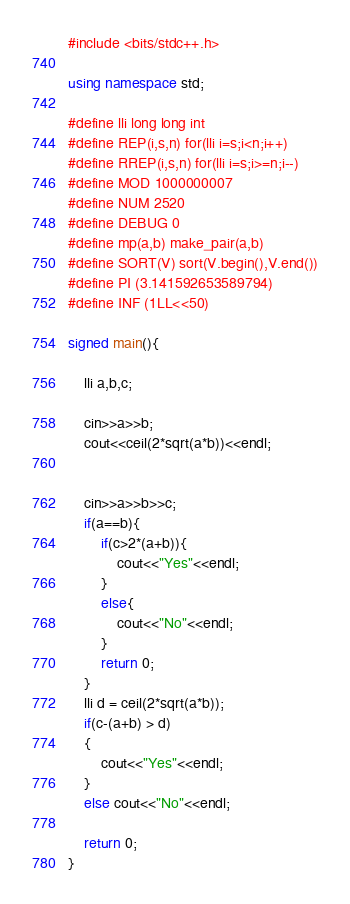<code> <loc_0><loc_0><loc_500><loc_500><_C++_>#include <bits/stdc++.h>

using namespace std;

#define lli long long int
#define REP(i,s,n) for(lli i=s;i<n;i++)
#define RREP(i,s,n) for(lli i=s;i>=n;i--)
#define MOD 1000000007
#define NUM 2520
#define DEBUG 0
#define mp(a,b) make_pair(a,b)
#define SORT(V) sort(V.begin(),V.end())
#define PI (3.141592653589794)
#define INF (1LL<<50)

signed main(){

	lli a,b,c;

	cin>>a>>b;
	cout<<ceil(2*sqrt(a*b))<<endl;
	

	cin>>a>>b>>c;
	if(a==b){
		if(c>2*(a+b)){
			cout<<"Yes"<<endl;
		}
		else{
			cout<<"No"<<endl;
		}
		return 0;
	}
	lli d = ceil(2*sqrt(a*b));
	if(c-(a+b) > d)
	{
		cout<<"Yes"<<endl;
	}
	else cout<<"No"<<endl;

	return 0;
}
</code> 